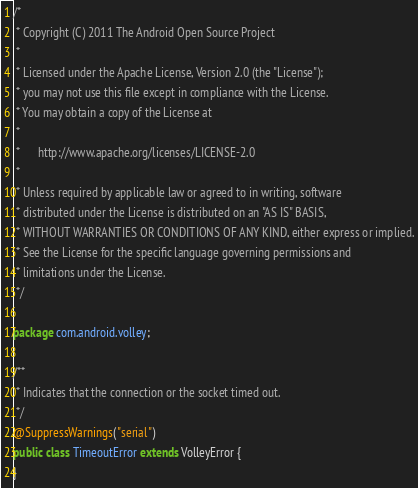Convert code to text. <code><loc_0><loc_0><loc_500><loc_500><_Java_>/*
 * Copyright (C) 2011 The Android Open Source Project
 *
 * Licensed under the Apache License, Version 2.0 (the "License");
 * you may not use this file except in compliance with the License.
 * You may obtain a copy of the License at
 *
 *      http://www.apache.org/licenses/LICENSE-2.0
 *
 * Unless required by applicable law or agreed to in writing, software
 * distributed under the License is distributed on an "AS IS" BASIS,
 * WITHOUT WARRANTIES OR CONDITIONS OF ANY KIND, either express or implied.
 * See the License for the specific language governing permissions and
 * limitations under the License.
 */

package com.android.volley;

/**
 * Indicates that the connection or the socket timed out.
 */
@SuppressWarnings("serial")
public class TimeoutError extends VolleyError {
}
</code> 